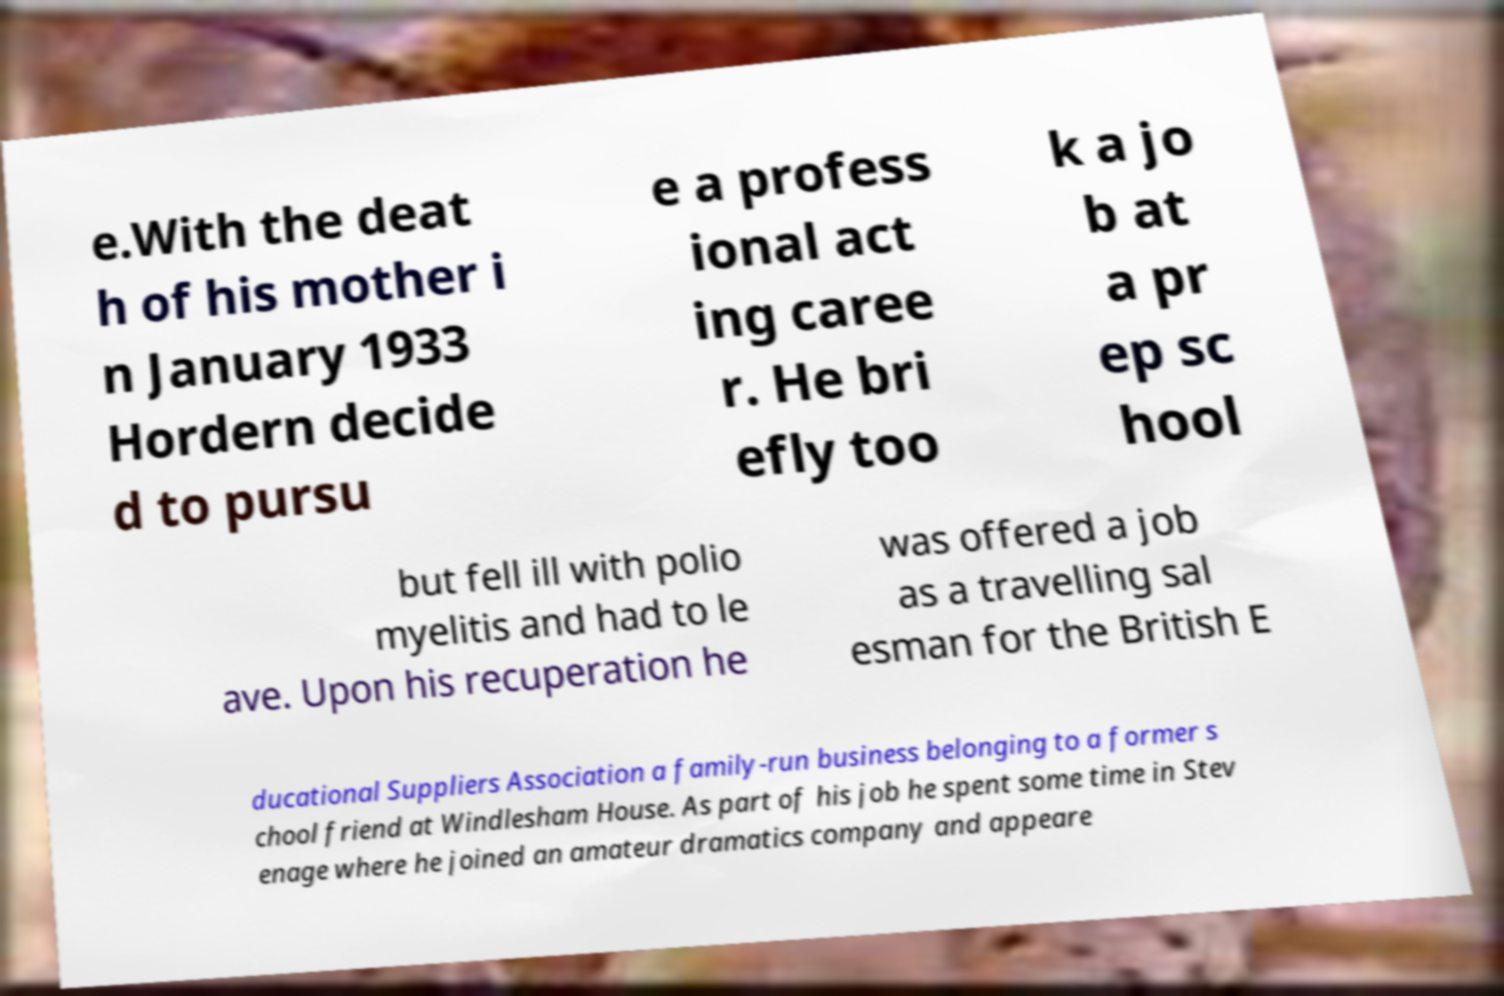Please read and relay the text visible in this image. What does it say? e.With the deat h of his mother i n January 1933 Hordern decide d to pursu e a profess ional act ing caree r. He bri efly too k a jo b at a pr ep sc hool but fell ill with polio myelitis and had to le ave. Upon his recuperation he was offered a job as a travelling sal esman for the British E ducational Suppliers Association a family-run business belonging to a former s chool friend at Windlesham House. As part of his job he spent some time in Stev enage where he joined an amateur dramatics company and appeare 